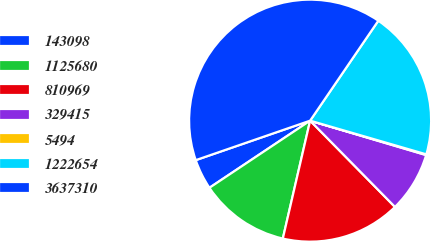<chart> <loc_0><loc_0><loc_500><loc_500><pie_chart><fcel>143098<fcel>1125680<fcel>810969<fcel>329415<fcel>5494<fcel>1222654<fcel>3637310<nl><fcel>4.07%<fcel>12.02%<fcel>15.99%<fcel>8.04%<fcel>0.1%<fcel>19.96%<fcel>39.82%<nl></chart> 